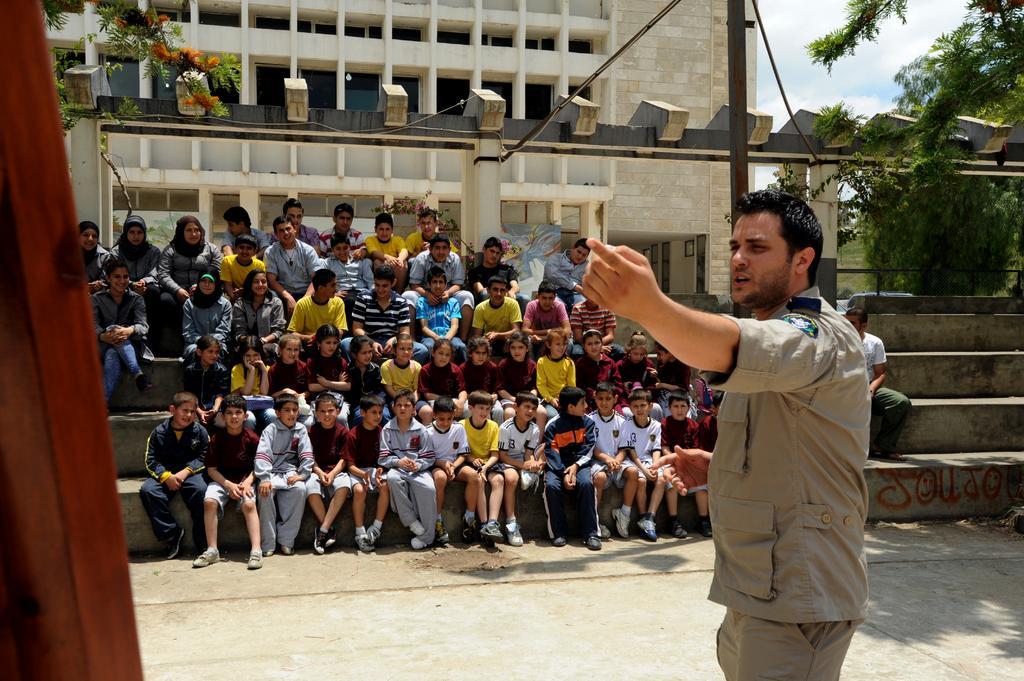Describe this image in one or two sentences. In this image in the foreground there is one man who is standing and it seems that he is talking something. In the background there are some children who are sitting and also there are some stairs, in the background there are some buildings, trees, pillars and some ropes. On the left side there is a wooden stick, at the bottom there is a walkway. 